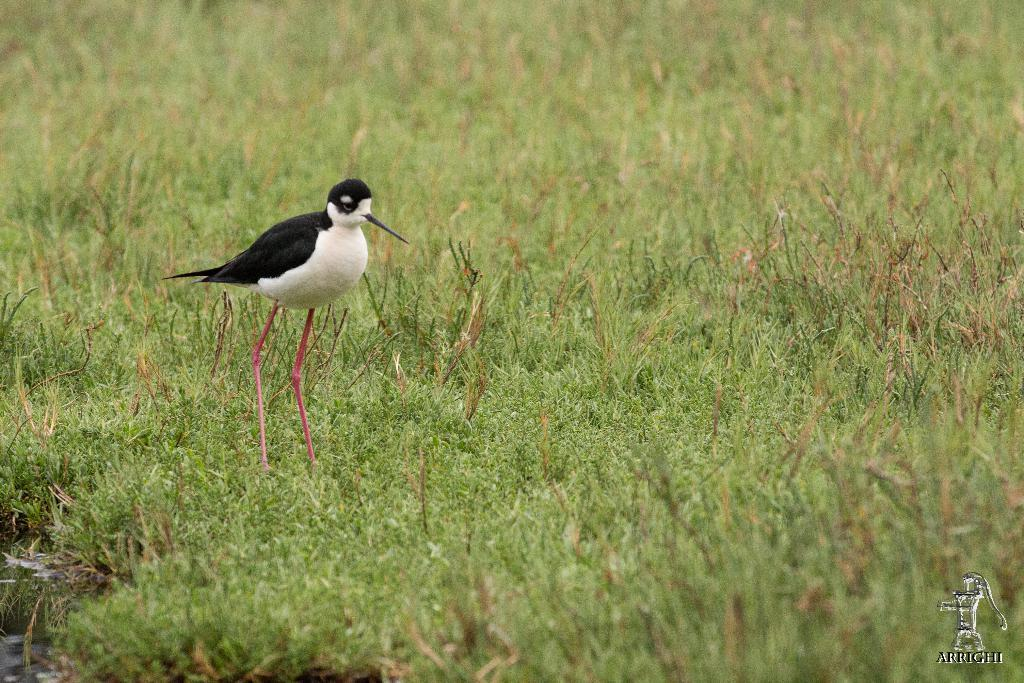What type of animal can be seen in the image? There is a bird in the image. Where is the bird located? The bird is on the grass. What type of box is the bird sitting on in the image? There is no box present in the image; the bird is on the grass. What season is depicted in the image? The provided facts do not mention any specific season, so it cannot be determined from the image. 